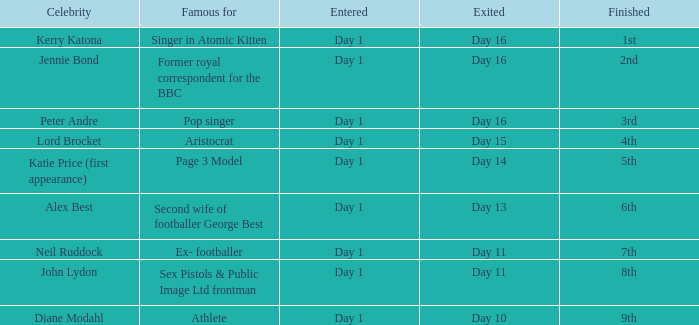Indicate the accomplished for gone of day 1 6th. 